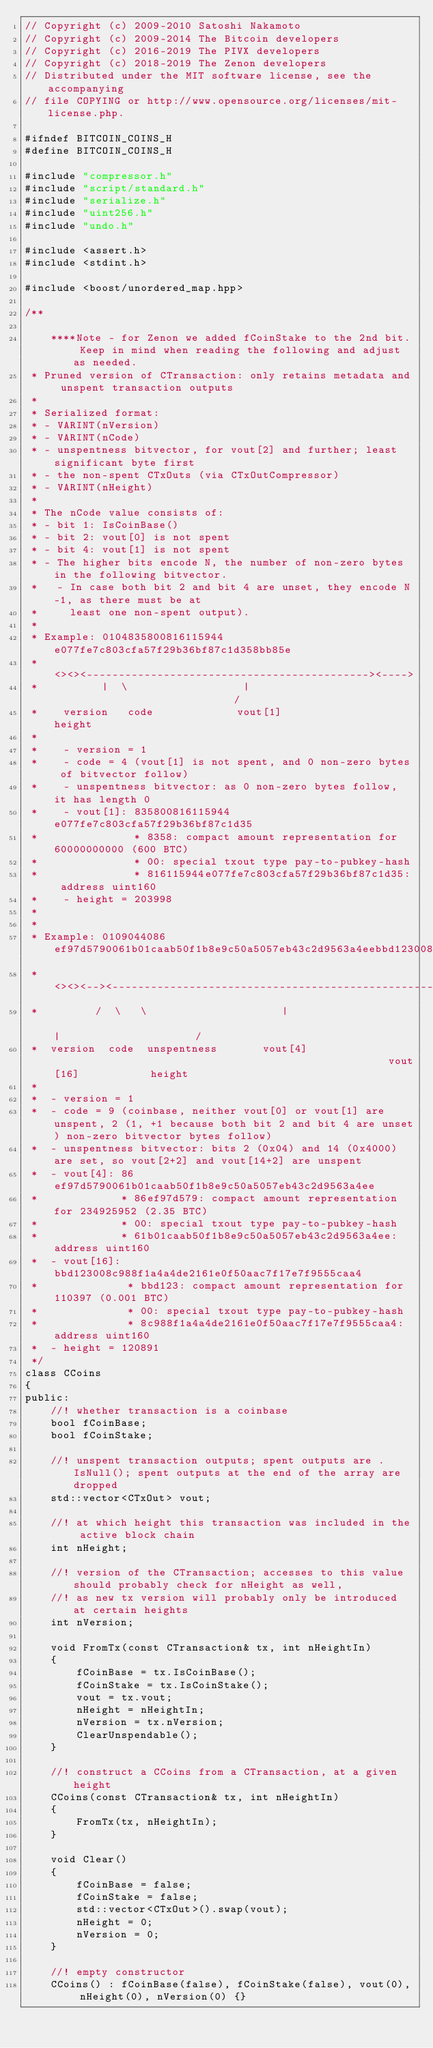Convert code to text. <code><loc_0><loc_0><loc_500><loc_500><_C_>// Copyright (c) 2009-2010 Satoshi Nakamoto
// Copyright (c) 2009-2014 The Bitcoin developers
// Copyright (c) 2016-2019 The PIVX developers
// Copyright (c) 2018-2019 The Zenon developers
// Distributed under the MIT software license, see the accompanying
// file COPYING or http://www.opensource.org/licenses/mit-license.php.

#ifndef BITCOIN_COINS_H
#define BITCOIN_COINS_H

#include "compressor.h"
#include "script/standard.h"
#include "serialize.h"
#include "uint256.h"
#include "undo.h"

#include <assert.h>
#include <stdint.h>

#include <boost/unordered_map.hpp>

/** 

    ****Note - for Zenon we added fCoinStake to the 2nd bit. Keep in mind when reading the following and adjust as needed.
 * Pruned version of CTransaction: only retains metadata and unspent transaction outputs
 *
 * Serialized format:
 * - VARINT(nVersion)
 * - VARINT(nCode)
 * - unspentness bitvector, for vout[2] and further; least significant byte first
 * - the non-spent CTxOuts (via CTxOutCompressor)
 * - VARINT(nHeight)
 *
 * The nCode value consists of:
 * - bit 1: IsCoinBase()
 * - bit 2: vout[0] is not spent
 * - bit 4: vout[1] is not spent
 * - The higher bits encode N, the number of non-zero bytes in the following bitvector.
 *   - In case both bit 2 and bit 4 are unset, they encode N-1, as there must be at
 *     least one non-spent output).
 *
 * Example: 0104835800816115944e077fe7c803cfa57f29b36bf87c1d358bb85e
 *          <><><--------------------------------------------><---->
 *          |  \                  |                             /
 *    version   code             vout[1]                  height
 *
 *    - version = 1
 *    - code = 4 (vout[1] is not spent, and 0 non-zero bytes of bitvector follow)
 *    - unspentness bitvector: as 0 non-zero bytes follow, it has length 0
 *    - vout[1]: 835800816115944e077fe7c803cfa57f29b36bf87c1d35
 *               * 8358: compact amount representation for 60000000000 (600 BTC)
 *               * 00: special txout type pay-to-pubkey-hash
 *               * 816115944e077fe7c803cfa57f29b36bf87c1d35: address uint160
 *    - height = 203998
 *
 *
 * Example: 0109044086ef97d5790061b01caab50f1b8e9c50a5057eb43c2d9563a4eebbd123008c988f1a4a4de2161e0f50aac7f17e7f9555caa486af3b
 *          <><><--><--------------------------------------------------><----------------------------------------------><---->
 *         /  \   \                     |                                                           |                     /
 *  version  code  unspentness       vout[4]                                                     vout[16]           height
 *
 *  - version = 1
 *  - code = 9 (coinbase, neither vout[0] or vout[1] are unspent, 2 (1, +1 because both bit 2 and bit 4 are unset) non-zero bitvector bytes follow)
 *  - unspentness bitvector: bits 2 (0x04) and 14 (0x4000) are set, so vout[2+2] and vout[14+2] are unspent
 *  - vout[4]: 86ef97d5790061b01caab50f1b8e9c50a5057eb43c2d9563a4ee
 *             * 86ef97d579: compact amount representation for 234925952 (2.35 BTC)
 *             * 00: special txout type pay-to-pubkey-hash
 *             * 61b01caab50f1b8e9c50a5057eb43c2d9563a4ee: address uint160
 *  - vout[16]: bbd123008c988f1a4a4de2161e0f50aac7f17e7f9555caa4
 *              * bbd123: compact amount representation for 110397 (0.001 BTC)
 *              * 00: special txout type pay-to-pubkey-hash
 *              * 8c988f1a4a4de2161e0f50aac7f17e7f9555caa4: address uint160
 *  - height = 120891
 */
class CCoins
{
public:
    //! whether transaction is a coinbase
    bool fCoinBase;
    bool fCoinStake;

    //! unspent transaction outputs; spent outputs are .IsNull(); spent outputs at the end of the array are dropped
    std::vector<CTxOut> vout;

    //! at which height this transaction was included in the active block chain
    int nHeight;

    //! version of the CTransaction; accesses to this value should probably check for nHeight as well,
    //! as new tx version will probably only be introduced at certain heights
    int nVersion;

    void FromTx(const CTransaction& tx, int nHeightIn)
    {
        fCoinBase = tx.IsCoinBase();
        fCoinStake = tx.IsCoinStake();
        vout = tx.vout;
        nHeight = nHeightIn;
        nVersion = tx.nVersion;
        ClearUnspendable();
    }

    //! construct a CCoins from a CTransaction, at a given height
    CCoins(const CTransaction& tx, int nHeightIn)
    {
        FromTx(tx, nHeightIn);
    }

    void Clear()
    {
        fCoinBase = false;
        fCoinStake = false;
        std::vector<CTxOut>().swap(vout);
        nHeight = 0;
        nVersion = 0;
    }

    //! empty constructor
    CCoins() : fCoinBase(false), fCoinStake(false), vout(0), nHeight(0), nVersion(0) {}
</code> 